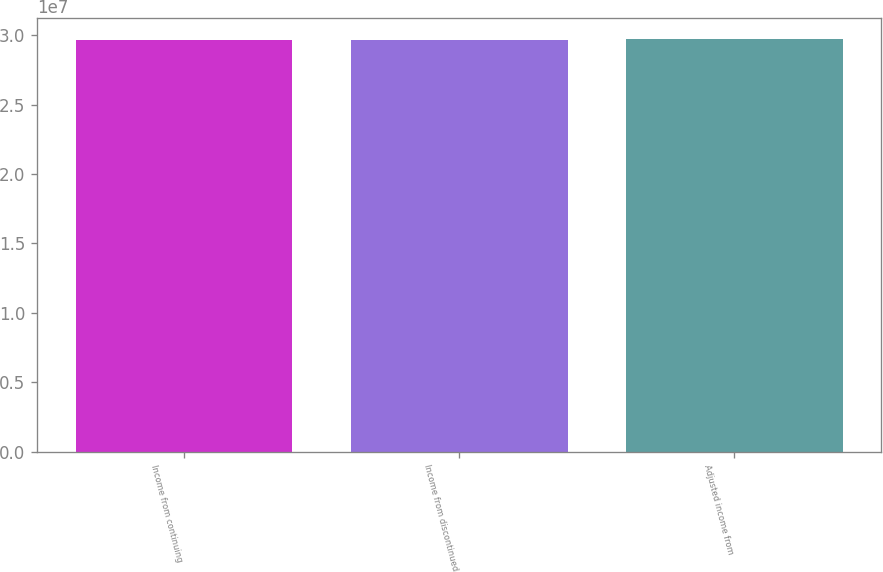Convert chart to OTSL. <chart><loc_0><loc_0><loc_500><loc_500><bar_chart><fcel>Income from continuing<fcel>Income from discontinued<fcel>Adjusted income from<nl><fcel>2.96671e+07<fcel>2.96738e+07<fcel>2.97411e+07<nl></chart> 